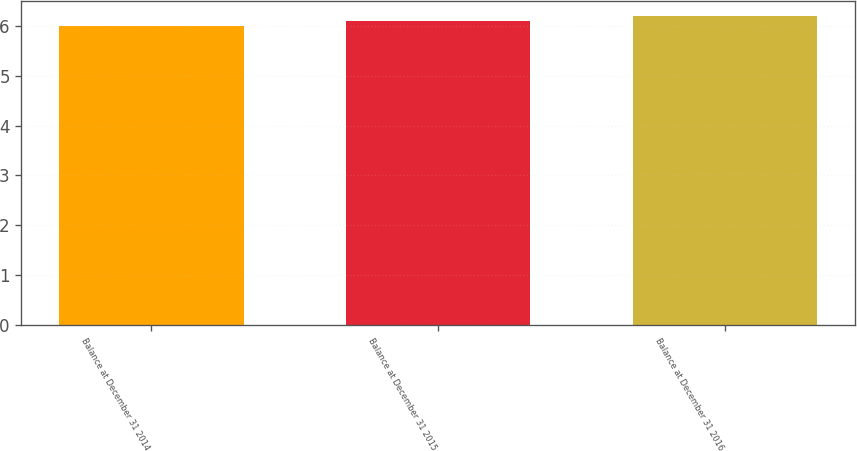<chart> <loc_0><loc_0><loc_500><loc_500><bar_chart><fcel>Balance at December 31 2014<fcel>Balance at December 31 2015<fcel>Balance at December 31 2016<nl><fcel>6<fcel>6.1<fcel>6.2<nl></chart> 